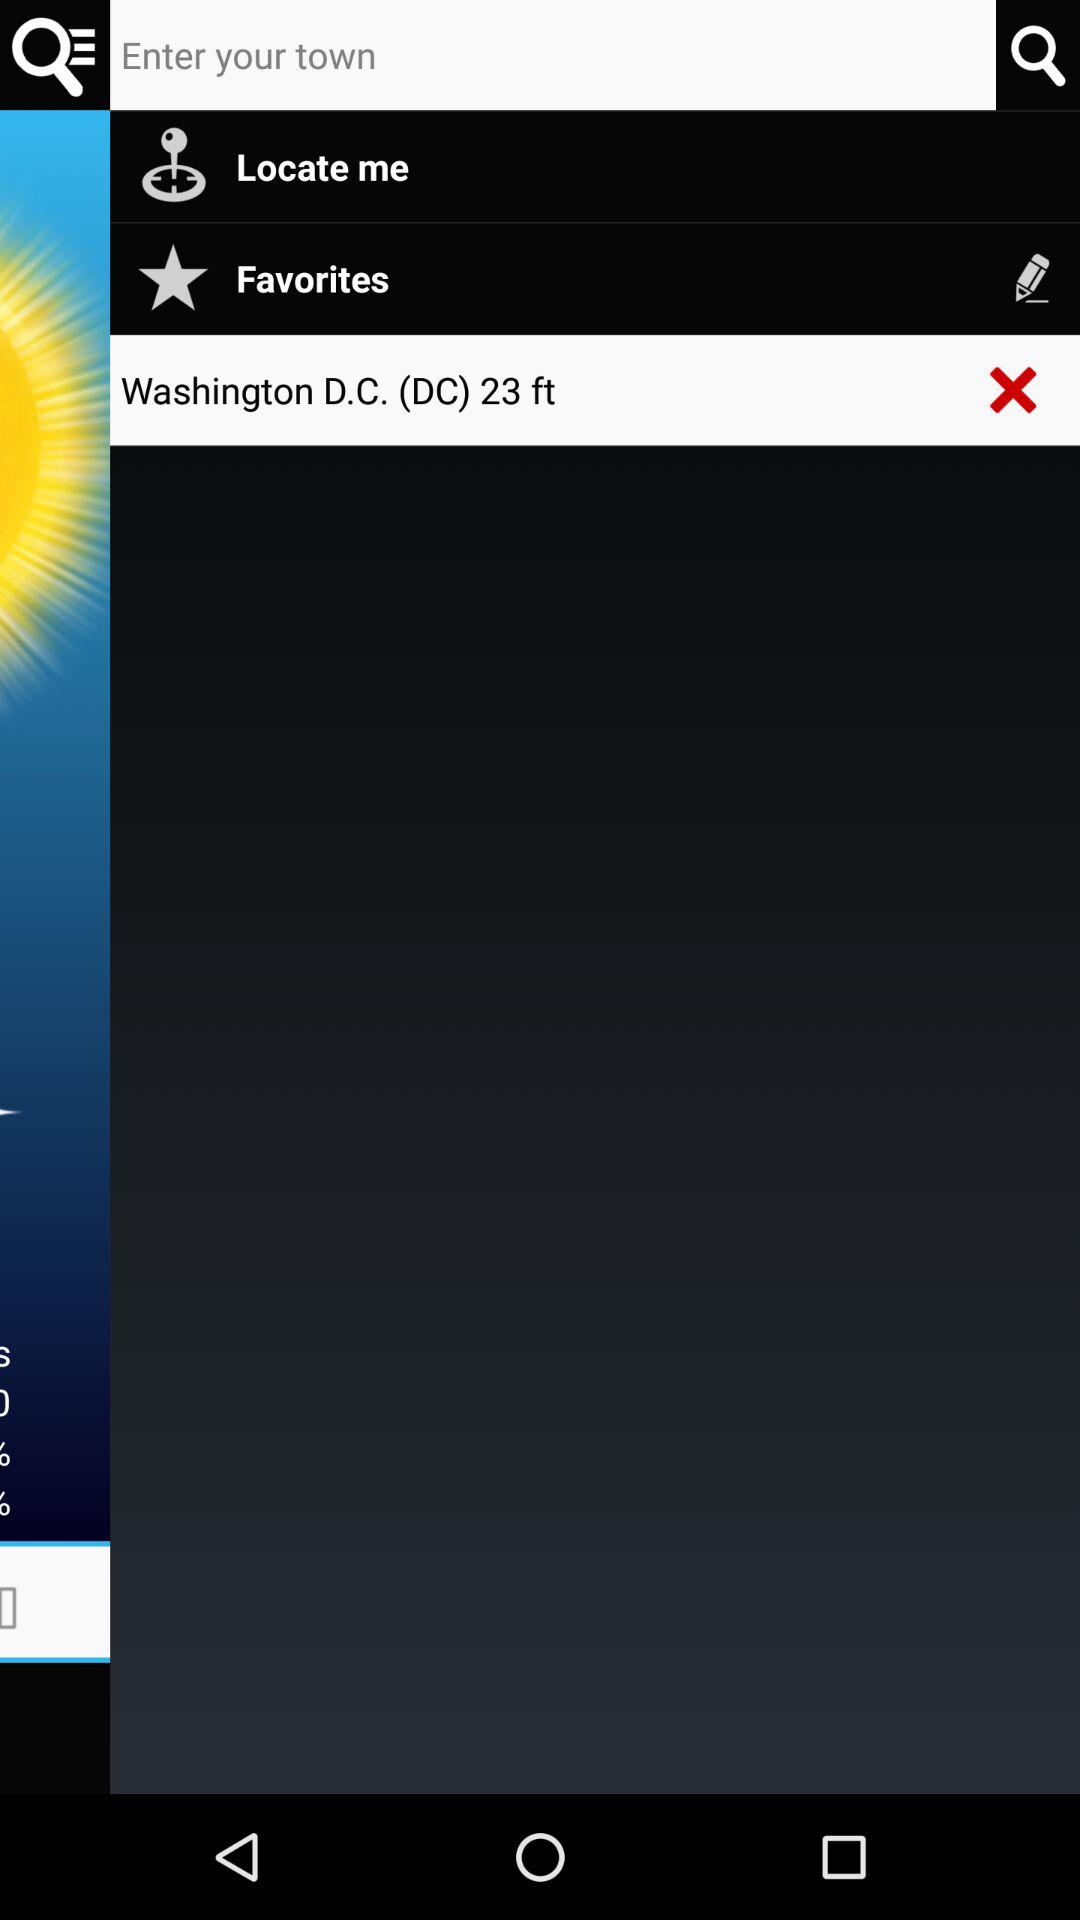What is the mentioned location? The mentioned location is Washington, D.C. 